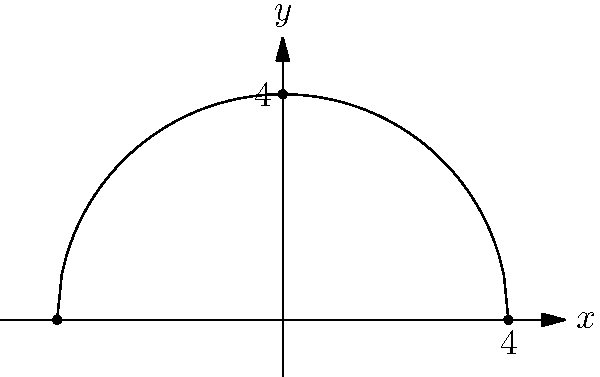A curved solar window is designed in the shape of a quarter circle with a radius of 4 meters. The window's energy output is proportional to its area. If the energy output of a 1 square meter flat panel is 150 watts, what is the total energy output of this curved solar window? To solve this problem, we need to follow these steps:

1) First, we need to calculate the area of the quarter circle. The formula for the area of a circle is $A = \pi r^2$, where $r$ is the radius.

2) For a quarter circle, we use a quarter of this area:

   $A = \frac{1}{4} \pi r^2$

3) Substituting $r = 4$ meters:

   $A = \frac{1}{4} \pi (4)^2 = 4\pi$ square meters

4) Now, we know that 1 square meter produces 150 watts. So, we can set up a proportion:

   $\frac{150 \text{ watts}}{1 \text{ m}^2} = \frac{x \text{ watts}}{4\pi \text{ m}^2}$

5) Cross multiply:

   $150 * 4\pi = x$

6) Simplify:

   $x = 600\pi$ watts

Therefore, the total energy output of the curved solar window is $600\pi$ watts.
Answer: $600\pi$ watts 